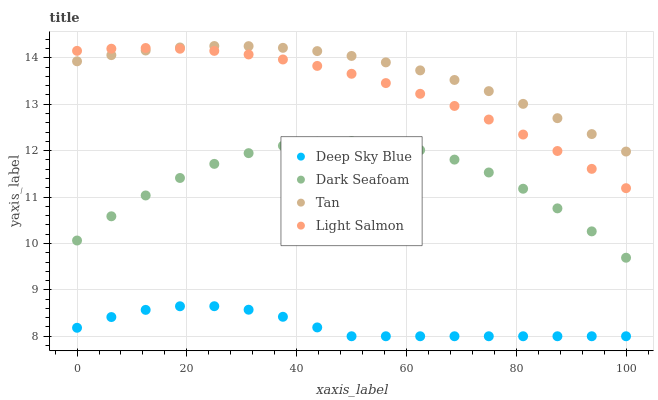Does Deep Sky Blue have the minimum area under the curve?
Answer yes or no. Yes. Does Tan have the maximum area under the curve?
Answer yes or no. Yes. Does Tan have the minimum area under the curve?
Answer yes or no. No. Does Deep Sky Blue have the maximum area under the curve?
Answer yes or no. No. Is Light Salmon the smoothest?
Answer yes or no. Yes. Is Dark Seafoam the roughest?
Answer yes or no. Yes. Is Tan the smoothest?
Answer yes or no. No. Is Tan the roughest?
Answer yes or no. No. Does Deep Sky Blue have the lowest value?
Answer yes or no. Yes. Does Tan have the lowest value?
Answer yes or no. No. Does Tan have the highest value?
Answer yes or no. Yes. Does Deep Sky Blue have the highest value?
Answer yes or no. No. Is Dark Seafoam less than Light Salmon?
Answer yes or no. Yes. Is Tan greater than Deep Sky Blue?
Answer yes or no. Yes. Does Light Salmon intersect Tan?
Answer yes or no. Yes. Is Light Salmon less than Tan?
Answer yes or no. No. Is Light Salmon greater than Tan?
Answer yes or no. No. Does Dark Seafoam intersect Light Salmon?
Answer yes or no. No. 